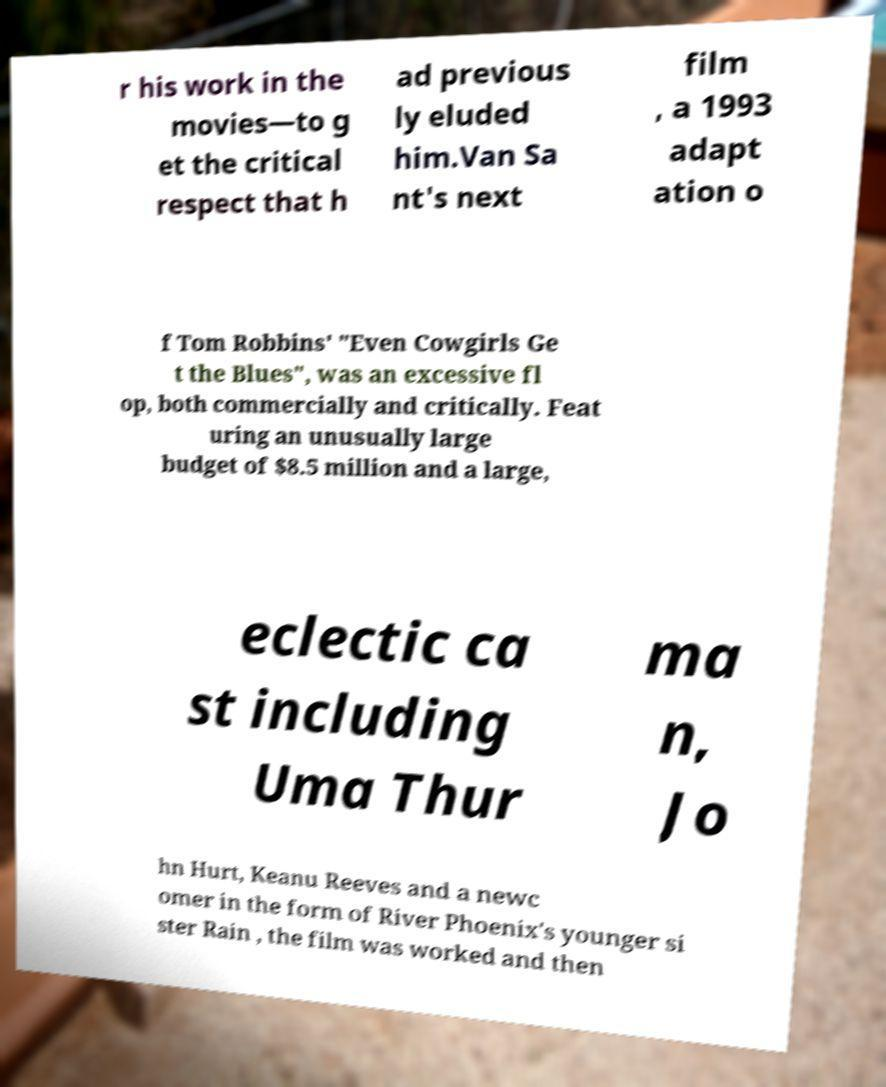Please read and relay the text visible in this image. What does it say? r his work in the movies—to g et the critical respect that h ad previous ly eluded him.Van Sa nt's next film , a 1993 adapt ation o f Tom Robbins' "Even Cowgirls Ge t the Blues", was an excessive fl op, both commercially and critically. Feat uring an unusually large budget of $8.5 million and a large, eclectic ca st including Uma Thur ma n, Jo hn Hurt, Keanu Reeves and a newc omer in the form of River Phoenix's younger si ster Rain , the film was worked and then 